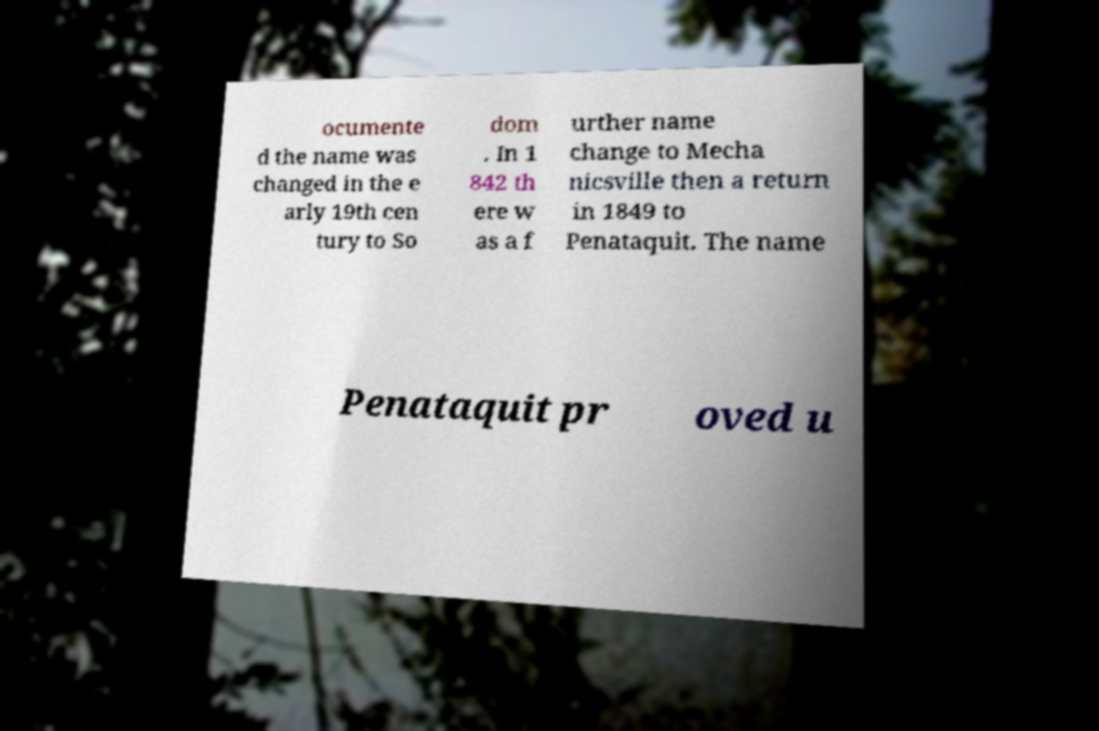Can you read and provide the text displayed in the image?This photo seems to have some interesting text. Can you extract and type it out for me? ocumente d the name was changed in the e arly 19th cen tury to So dom . In 1 842 th ere w as a f urther name change to Mecha nicsville then a return in 1849 to Penataquit. The name Penataquit pr oved u 